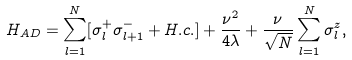<formula> <loc_0><loc_0><loc_500><loc_500>H _ { A D } = \sum _ { l = 1 } ^ { N } [ \sigma _ { l } ^ { + } \sigma _ { l + 1 } ^ { - } + H . c . ] + \frac { \nu ^ { 2 } } { 4 \lambda } + \frac { \nu } { \sqrt { N } } \sum _ { l = 1 } ^ { N } \sigma _ { l } ^ { z } ,</formula> 